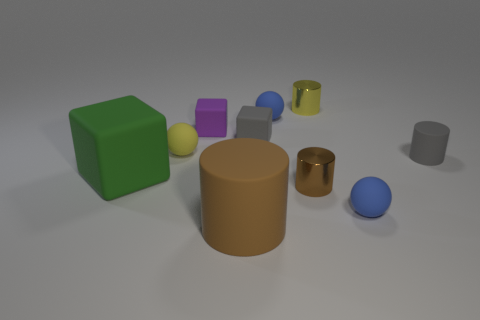Subtract all tiny matte cylinders. How many cylinders are left? 3 Subtract all balls. How many objects are left? 7 Subtract all gray cylinders. How many cylinders are left? 3 Subtract all purple blocks. Subtract all green cylinders. How many blocks are left? 2 Subtract all brown cylinders. How many cyan balls are left? 0 Subtract all small blue matte spheres. Subtract all yellow rubber objects. How many objects are left? 7 Add 1 small spheres. How many small spheres are left? 4 Add 3 big matte things. How many big matte things exist? 5 Subtract 0 blue cubes. How many objects are left? 10 Subtract 1 cylinders. How many cylinders are left? 3 